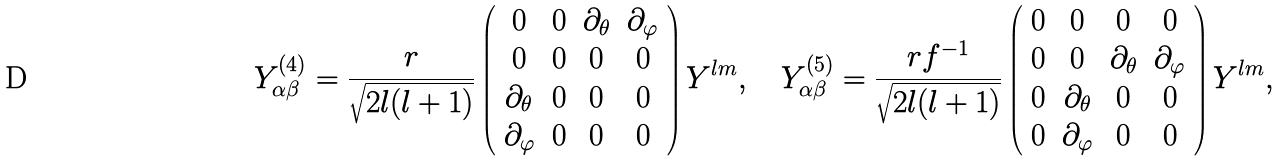<formula> <loc_0><loc_0><loc_500><loc_500>Y ^ { ( 4 ) } _ { \alpha \beta } = \frac { r } { \sqrt { 2 l ( l + 1 ) } } \left ( \begin{array} { c c c c } 0 & 0 & \partial _ { \theta } & \partial _ { \varphi } \\ 0 & 0 & 0 & 0 \\ \partial _ { \theta } & 0 & 0 & 0 \\ \partial _ { \varphi } & 0 & 0 & 0 \end{array} \right ) Y ^ { l m } , \quad Y ^ { ( 5 ) } _ { \alpha \beta } = \frac { r f ^ { - 1 } } { \sqrt { 2 l ( l + 1 ) } } \left ( \begin{array} { c c c c } 0 & 0 & 0 & 0 \\ 0 & 0 & \partial _ { \theta } & \partial _ { \varphi } \\ 0 & \partial _ { \theta } & 0 & 0 \\ 0 & \partial _ { \varphi } & 0 & 0 \end{array} \right ) Y ^ { l m } ,</formula> 